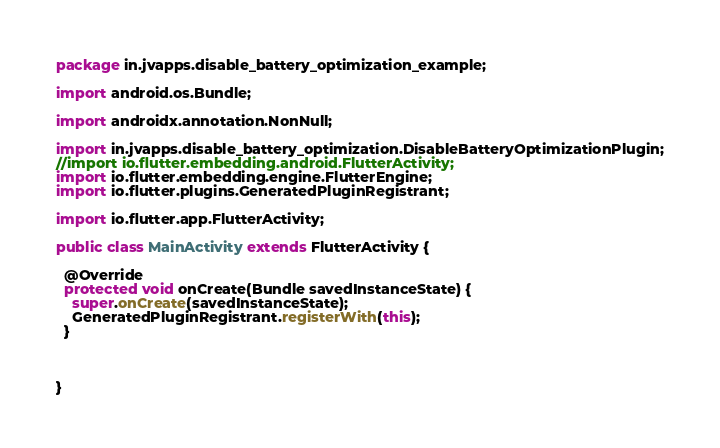Convert code to text. <code><loc_0><loc_0><loc_500><loc_500><_Java_>package in.jvapps.disable_battery_optimization_example;

import android.os.Bundle;

import androidx.annotation.NonNull;

import in.jvapps.disable_battery_optimization.DisableBatteryOptimizationPlugin;
//import io.flutter.embedding.android.FlutterActivity;
import io.flutter.embedding.engine.FlutterEngine;
import io.flutter.plugins.GeneratedPluginRegistrant;

import io.flutter.app.FlutterActivity;

public class MainActivity extends FlutterActivity {

  @Override
  protected void onCreate(Bundle savedInstanceState) {
    super.onCreate(savedInstanceState);
    GeneratedPluginRegistrant.registerWith(this);
  }



}
</code> 